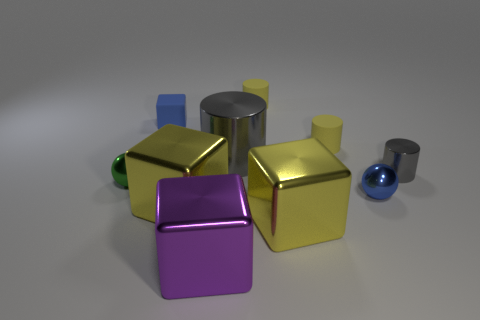What is the material of the small blue object that is the same shape as the purple shiny object?
Offer a terse response. Rubber. How many other metallic spheres have the same size as the blue metal ball?
Your answer should be very brief. 1. There is a tiny thing that is to the left of the big cylinder and right of the small green shiny thing; what is its color?
Offer a terse response. Blue. Is the number of metal blocks less than the number of purple things?
Provide a succinct answer. No. Is the color of the small block the same as the small cylinder that is behind the tiny cube?
Your answer should be compact. No. Is the number of tiny gray objects that are left of the blue cube the same as the number of shiny spheres behind the small blue metal thing?
Your answer should be very brief. No. How many blue shiny objects have the same shape as the green thing?
Ensure brevity in your answer.  1. Are any small green balls visible?
Keep it short and to the point. Yes. Do the tiny gray cylinder and the small blue thing that is behind the tiny green shiny sphere have the same material?
Your response must be concise. No. There is another sphere that is the same size as the green ball; what is it made of?
Your answer should be compact. Metal. 